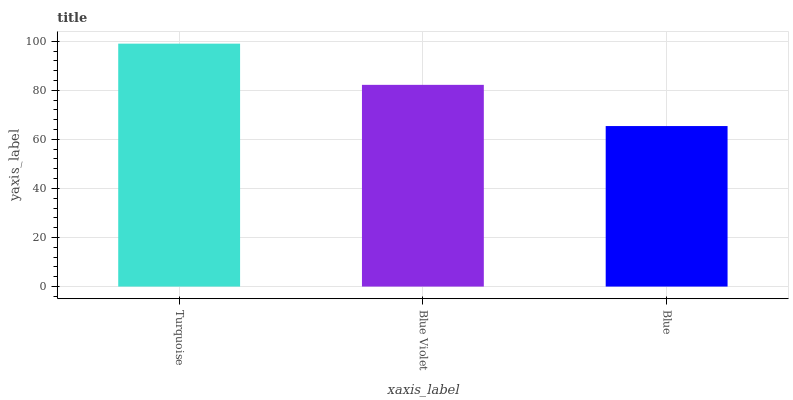Is Blue the minimum?
Answer yes or no. Yes. Is Turquoise the maximum?
Answer yes or no. Yes. Is Blue Violet the minimum?
Answer yes or no. No. Is Blue Violet the maximum?
Answer yes or no. No. Is Turquoise greater than Blue Violet?
Answer yes or no. Yes. Is Blue Violet less than Turquoise?
Answer yes or no. Yes. Is Blue Violet greater than Turquoise?
Answer yes or no. No. Is Turquoise less than Blue Violet?
Answer yes or no. No. Is Blue Violet the high median?
Answer yes or no. Yes. Is Blue Violet the low median?
Answer yes or no. Yes. Is Blue the high median?
Answer yes or no. No. Is Turquoise the low median?
Answer yes or no. No. 